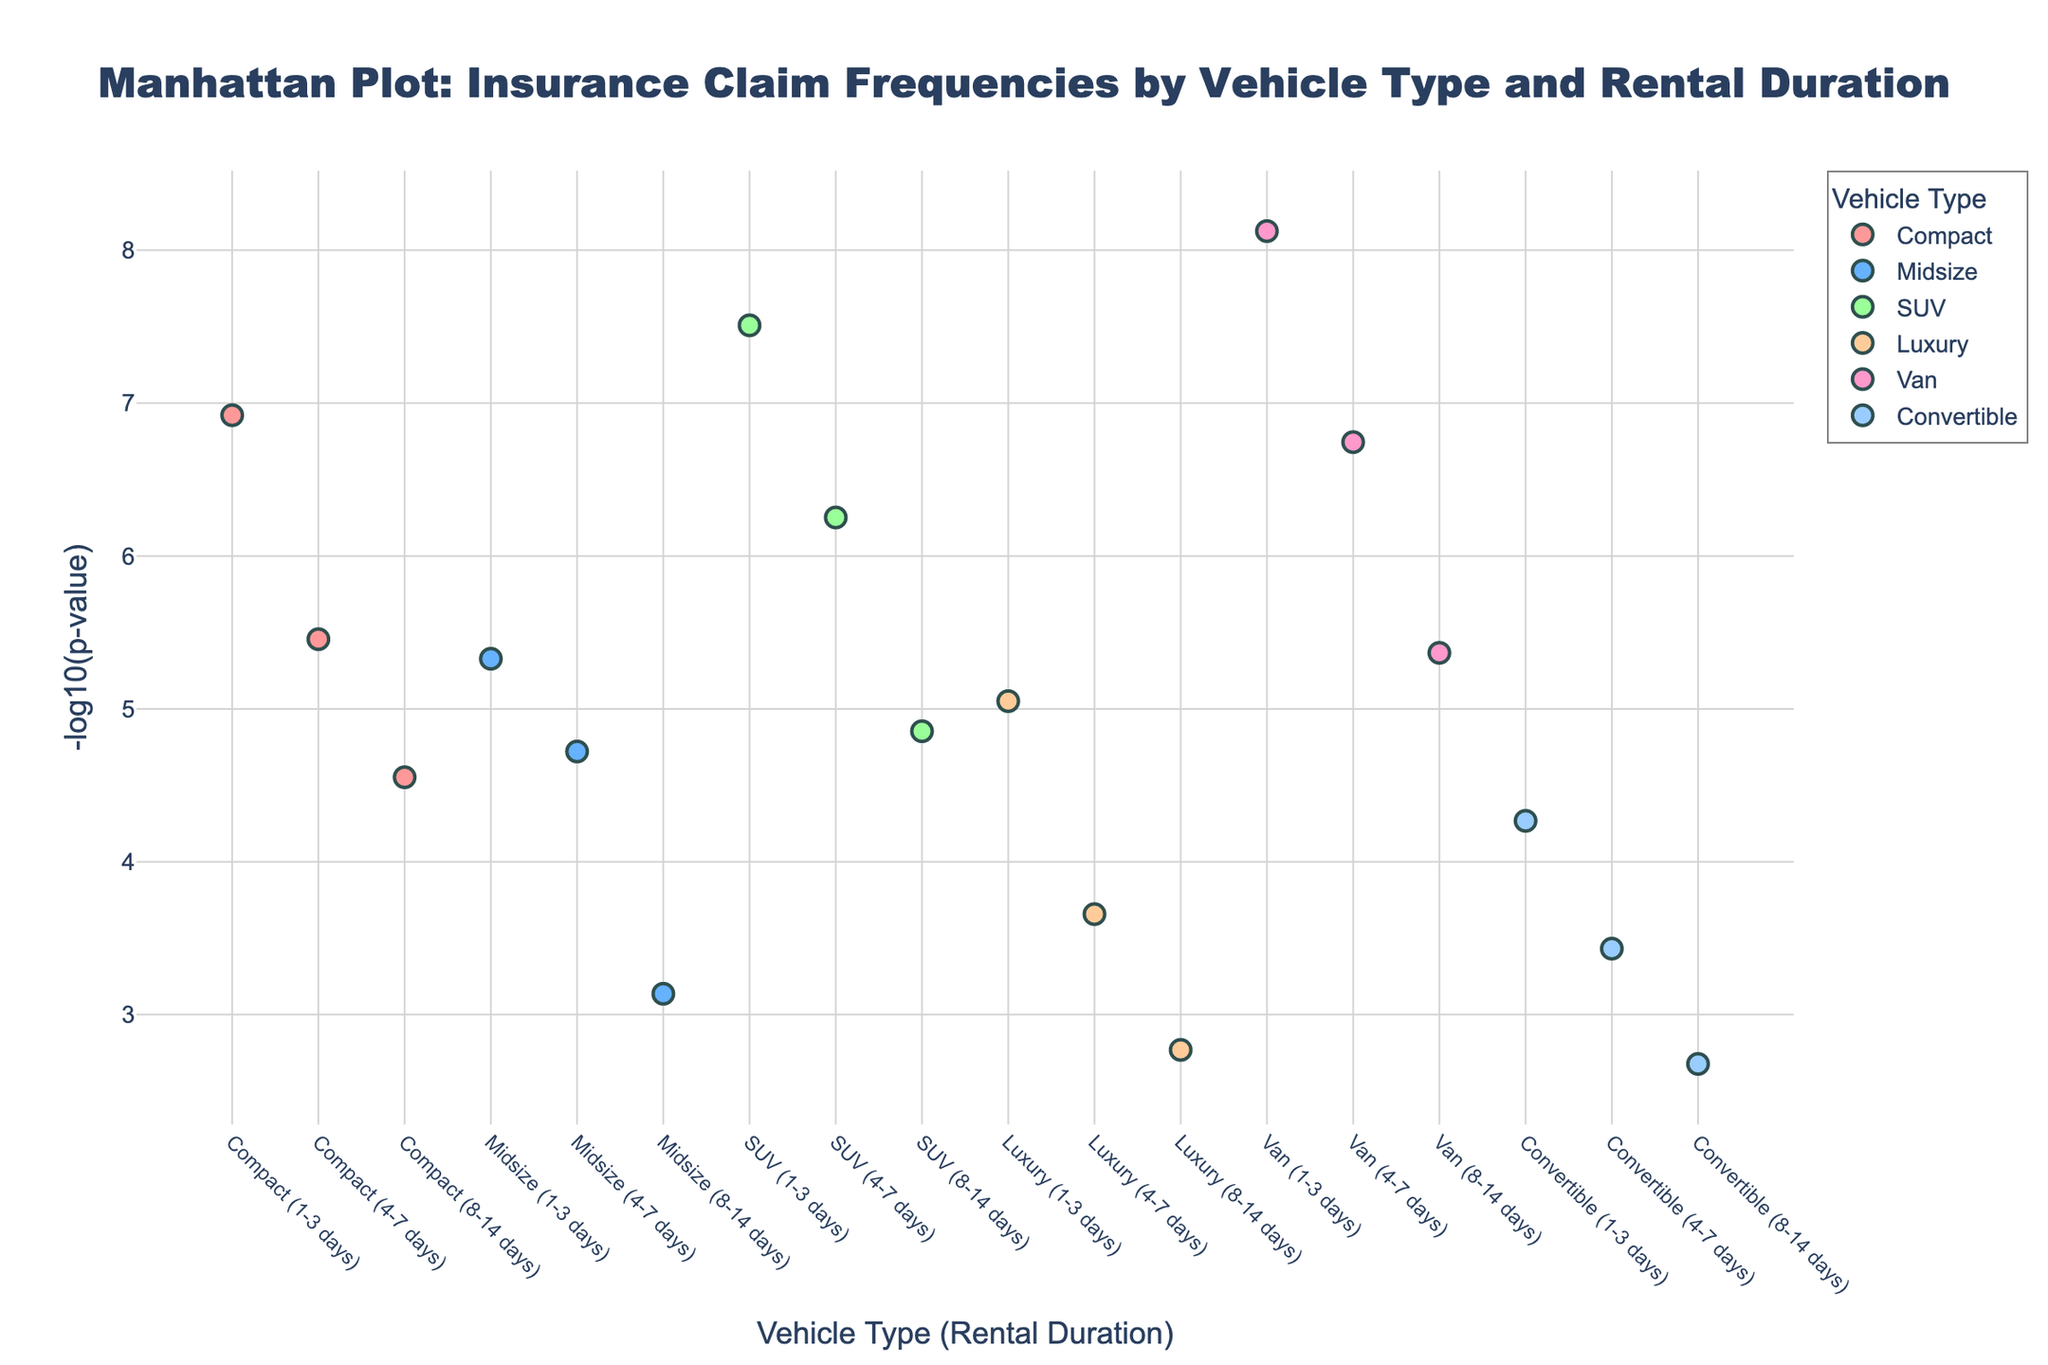What is the title of the Manhattan Plot? The title is located at the top of the plot and reads clearly. It provides the main description of what the plot represents.
Answer: Manhattan Plot: Insurance Claim Frequencies by Vehicle Type and Rental Duration Which vehicle type and rental duration combination has the highest claim frequency p-value? By examining the height of the markers on the y-axis, the highest point corresponds to the smallest p-value. The label on the x-axis will tell us the vehicle type and rental duration.
Answer: Van (1-3 days) How does the rental duration affect the insurance claim frequencies for SUVs? Observe the data points corresponding to SUVs across different rental durations. As duration increases from 1-3 days to 8-14 days, the height of the points (negative log p-values) changes, indicating varying p-values.
Answer: The claim frequency increases with longer rental durations Which vehicle type has the most consistent p-values across all rental durations? Compare the spread of the negative log p-values for each vehicle type. The type with the least variation in height is the most consistent.
Answer: Luxury How do the insurance claim frequencies of Vans compare to Convertibles for the 8-14 day rental period? Locate the points for Vans and Convertibles for the 8-14 day period on the x-axis. Compare their heights to see the difference in negative log p-values.
Answer: Vans have a higher claim frequency than Convertibles What is the overall highest -log10(p-value) in the plot? Look for the tallest marker on the y-axis, which represents the highest -log10(p-value), and read its value.
Answer: 8.12 Between Compact and Midsize vehicles, which type has a higher average negative log p-value for all rental durations? Calculate the average negative log p-value for Compact and Midsize vehicles by averaging their points' heights. Compare these averages.
Answer: Midsize Identify a high-risk vehicle type for insurance claims for rentals longer than 7 days. High-risk categories have higher negative log p-values. Check the points for vehicle types with rental durations of 8-14 days and find the highest.
Answer: Van Which vehicle type has the most variation in claim frequencies across different rental durations? Determine the variability by looking at the range of negative log p-values for each vehicle type across rental durations. The type with the largest range has the most variation.
Answer: SUV Are insurance claim frequencies affected more by vehicle type or rental duration? To answer this, compare the spread of negative log p-values within each vehicle type and within each rental duration. If the points within vehicle types cluster closely together while points within rental durations vary widely (or vice versa), you can determine which factor has a larger impact.
Answer: Rental duration 